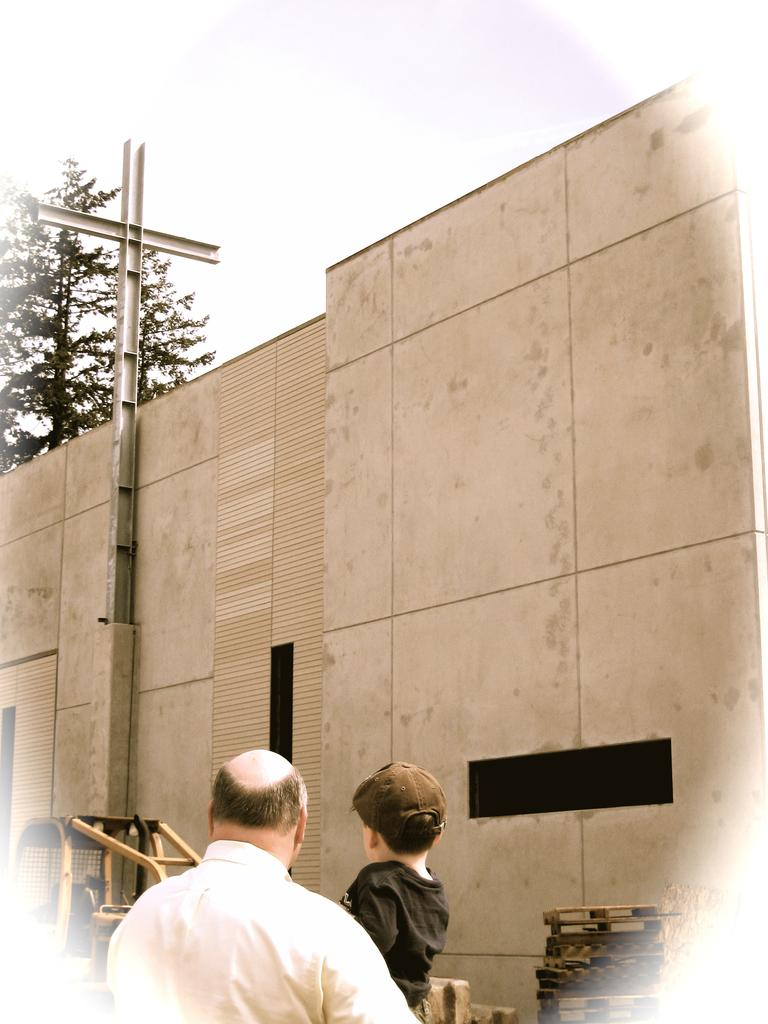Who are the people in the image? There is a man and a boy in the image. What is the man wearing? The man is wearing a white-colored dress. What is the boy wearing? The boy is wearing black. What can be seen in the background of the image? There is a wall, unspecified things, and a tree in the background of the image. How does the boy push the hall in the image? There is no hall present in the image, and the boy is not pushing anything. 